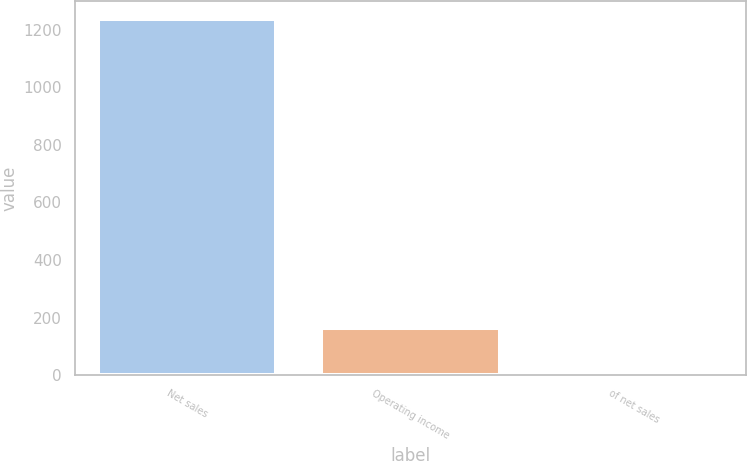Convert chart. <chart><loc_0><loc_0><loc_500><loc_500><bar_chart><fcel>Net sales<fcel>Operating income<fcel>of net sales<nl><fcel>1236.4<fcel>165<fcel>13.3<nl></chart> 